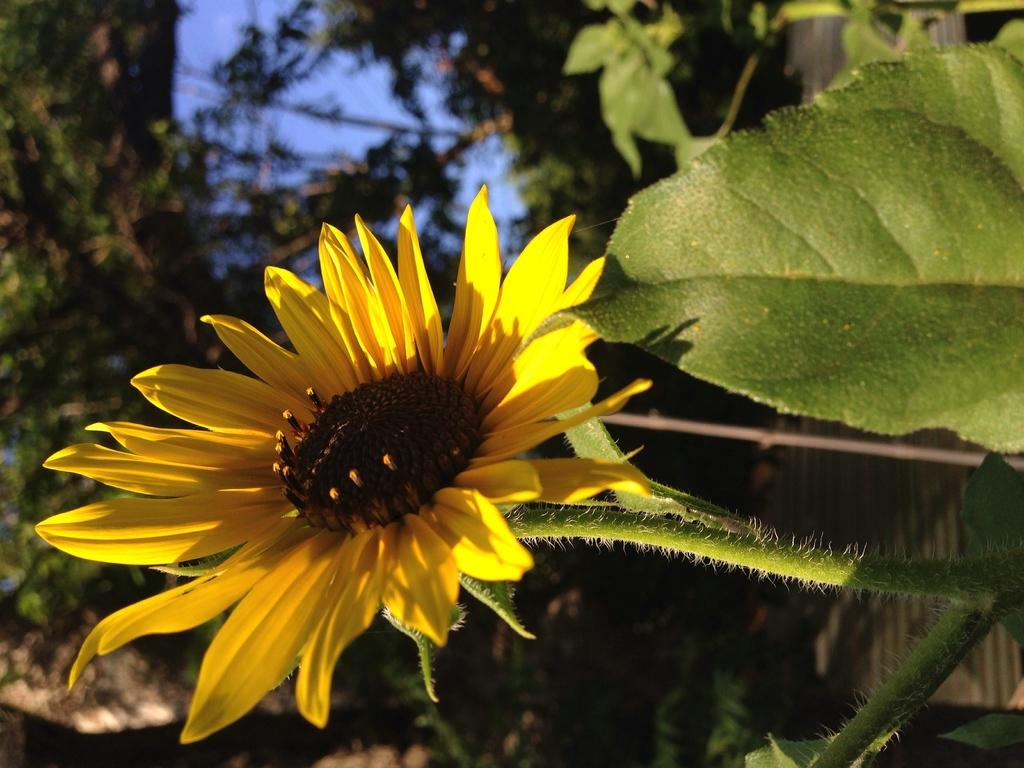What type of plant can be seen in the image? There is a flower in the image. image. What colors are present on the flower? The flower has yellow and brown colors. What other parts of the plant are visible in the image? There are green leaves in the image. What is the color of the sky in the image? The sky is blue in the image. Can you see any icicles forming on the flower in the image? There are no icicles present in the image; the flower has yellow and brown colors, and the sky is blue. 